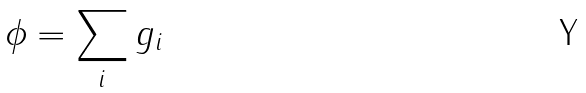Convert formula to latex. <formula><loc_0><loc_0><loc_500><loc_500>\phi = \sum _ { i } g _ { i }</formula> 